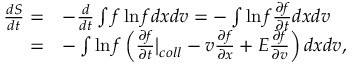<formula> <loc_0><loc_0><loc_500><loc_500>\begin{array} { r l } { \frac { d S } { d t } = } & { - \frac { d } { d t } \int f \ln f d x d v = - \int \ln f \frac { \partial f } { \partial t } d x d v } \\ { = } & { - \int \ln f \left ( \frac { \partial f } { \partial t } \Big | _ { c o l l } - v \frac { \partial f } { \partial x } + E \frac { \partial f } { \partial v } \right ) d x d v , } \end{array}</formula> 